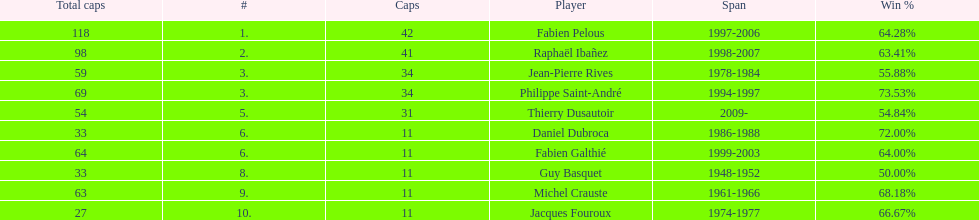How many caps did jean-pierre rives and michel crauste accrue? 122. 